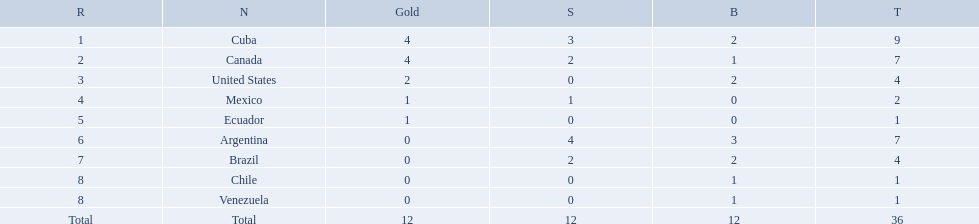What countries participated? Cuba, 4, 3, 2, Canada, 4, 2, 1, United States, 2, 0, 2, Mexico, 1, 1, 0, Ecuador, 1, 0, 0, Argentina, 0, 4, 3, Brazil, 0, 2, 2, Chile, 0, 0, 1, Venezuela, 0, 0, 1. What countries won 1 gold Mexico, 1, 1, 0, Ecuador, 1, 0, 0. What country above also won no silver? Ecuador. Which nations won a gold medal in canoeing in the 2011 pan american games? Cuba, Canada, United States, Mexico, Ecuador. Which of these did not win any silver medals? United States. What were the amounts of bronze medals won by the countries? 2, 1, 2, 0, 0, 3, 2, 1, 1. Which is the highest? 3. Which nation had this amount? Argentina. 